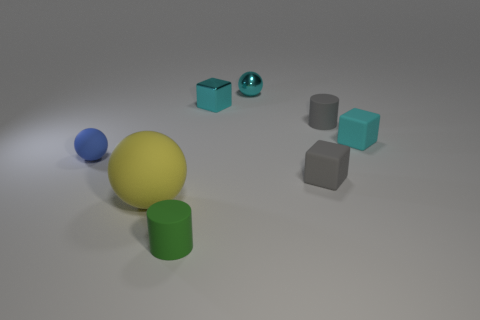Can you describe the different shapes you see in this image? Certainly! The image shows a variety of geometric shapes. There is a large yellow sphere, a small blue sphere, a green cylinder, and several cubes—three small matte teal ones and a larger shiny one that mirrors their shape but with a metallic surface. 